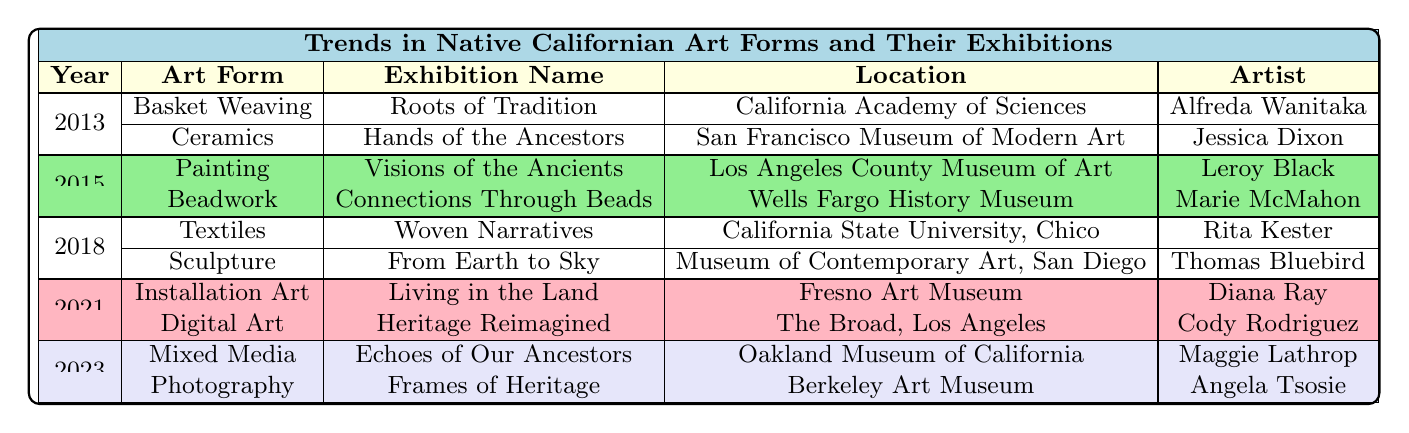What was the focus of the exhibition "Hands of the Ancestors"? According to the table, the exhibition "Hands of the Ancestors" is focused on "Modern Interpretations of Indigenous Pottery".
Answer: Modern Interpretations of Indigenous Pottery Which location hosted the exhibition "Echoes of Our Ancestors"? The table indicates that the exhibition "Echoes of Our Ancestors" was held at the "Oakland Museum of California."
Answer: Oakland Museum of California How many different art forms were exhibited in total across the years listed? From the table, there are 5 unique art forms mentioned: Basket Weaving, Ceramics, Painting, Beadwork, Textiles, Sculpture, Installation Art, Digital Art, Mixed Media, and Photography, totaling 10 distinct art forms.
Answer: 10 Was there a photography exhibition in the year 2021? By examining the table, there is no photography exhibition listed for the year 2021, which indicates the statement is false.
Answer: No Which artist had their work displayed in the 2018 exhibition "Woven Narratives"? The table shows that the artist associated with the "Woven Narratives" exhibition in 2018 is "Rita Kester."
Answer: Rita Kester What is the difference in the number of exhibitions between the years 2013 and 2023? In 2013, there are 2 exhibitions and in 2023 there are also 2 exhibitions, therefore the difference in the number of exhibitions is 0.
Answer: 0 Did the exhibition "Living in the Land" focus on traditional art forms? The table indicates that "Living in the Land" focuses on interactive installations engaging with Native Californian heritage, which points toward a modern interpretation rather than traditional art forms, making this statement false.
Answer: No Which art form had the highest number of exhibitions over the specified years? Analyzing the data, we count that each year had 2 exhibitions, leading us to conclude that no specific art form had a higher number of exhibitions since they all had 2.
Answer: None What year did the exhibition "Heritage Reimagined" take place? The table specifies that the exhibition "Heritage Reimagined" was held in the year 2021.
Answer: 2021 